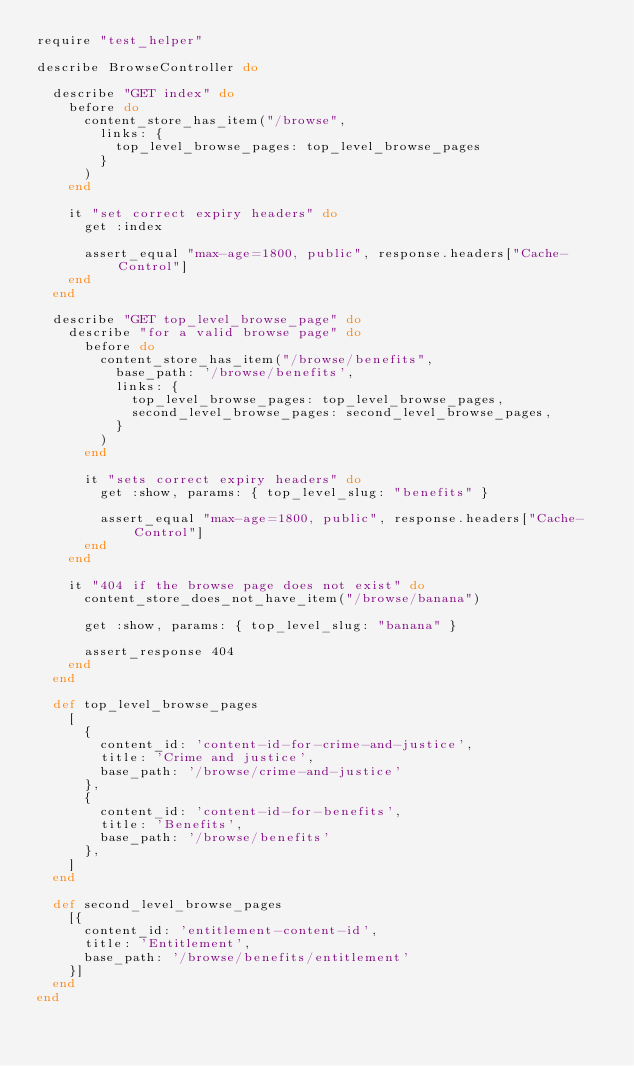<code> <loc_0><loc_0><loc_500><loc_500><_Ruby_>require "test_helper"

describe BrowseController do

  describe "GET index" do
    before do
      content_store_has_item("/browse",
        links: {
          top_level_browse_pages: top_level_browse_pages
        }
      )
    end

    it "set correct expiry headers" do
      get :index

      assert_equal "max-age=1800, public", response.headers["Cache-Control"]
    end
  end

  describe "GET top_level_browse_page" do
    describe "for a valid browse page" do
      before do
        content_store_has_item("/browse/benefits",
          base_path: '/browse/benefits',
          links: {
            top_level_browse_pages: top_level_browse_pages,
            second_level_browse_pages: second_level_browse_pages,
          }
        )
      end

      it "sets correct expiry headers" do
        get :show, params: { top_level_slug: "benefits" }

        assert_equal "max-age=1800, public", response.headers["Cache-Control"]
      end
    end

    it "404 if the browse page does not exist" do
      content_store_does_not_have_item("/browse/banana")

      get :show, params: { top_level_slug: "banana" }

      assert_response 404
    end
  end

  def top_level_browse_pages
    [
      {
        content_id: 'content-id-for-crime-and-justice',
        title: 'Crime and justice',
        base_path: '/browse/crime-and-justice'
      },
      {
        content_id: 'content-id-for-benefits',
        title: 'Benefits',
        base_path: '/browse/benefits'
      },
    ]
  end

  def second_level_browse_pages
    [{
      content_id: 'entitlement-content-id',
      title: 'Entitlement',
      base_path: '/browse/benefits/entitlement'
    }]
  end
end
</code> 